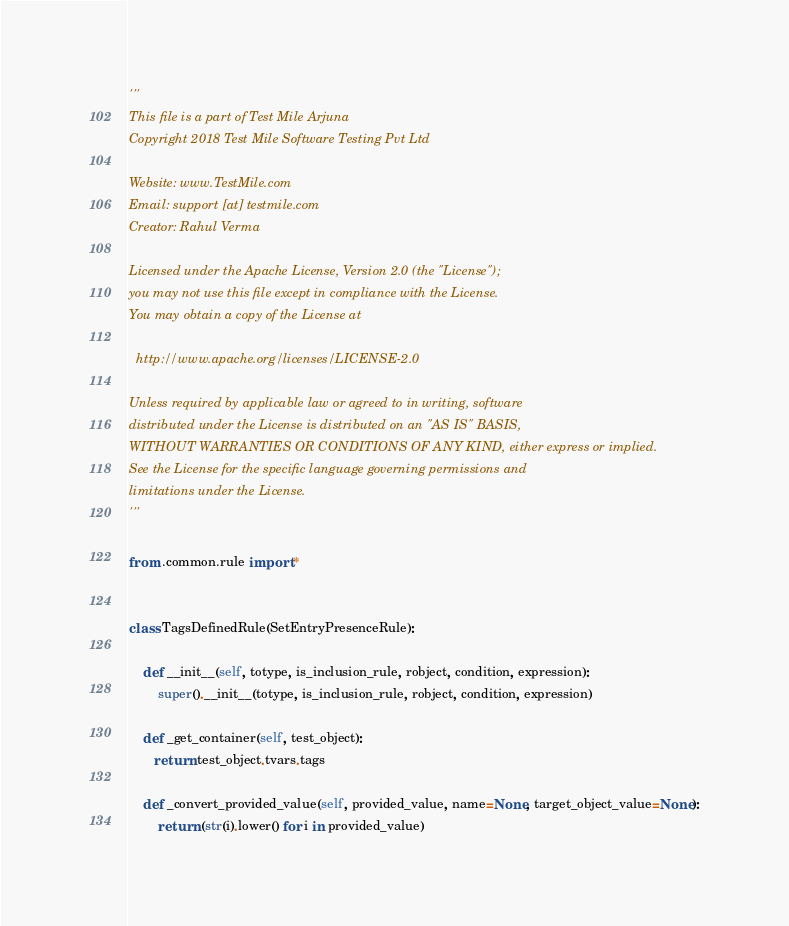<code> <loc_0><loc_0><loc_500><loc_500><_Python_>'''
This file is a part of Test Mile Arjuna
Copyright 2018 Test Mile Software Testing Pvt Ltd

Website: www.TestMile.com
Email: support [at] testmile.com
Creator: Rahul Verma

Licensed under the Apache License, Version 2.0 (the "License");
you may not use this file except in compliance with the License.
You may obtain a copy of the License at

  http://www.apache.org/licenses/LICENSE-2.0

Unless required by applicable law or agreed to in writing, software
distributed under the License is distributed on an "AS IS" BASIS,
WITHOUT WARRANTIES OR CONDITIONS OF ANY KIND, either express or implied.
See the License for the specific language governing permissions and
limitations under the License.
'''

from .common.rule import *


class TagsDefinedRule(SetEntryPresenceRule):

    def __init__(self, totype, is_inclusion_rule, robject, condition, expression):
        super().__init__(totype, is_inclusion_rule, robject, condition, expression)

    def _get_container(self, test_object):
       return test_object.tvars.tags

    def _convert_provided_value(self, provided_value, name=None, target_object_value=None):
        return (str(i).lower() for i in provided_value)

</code> 